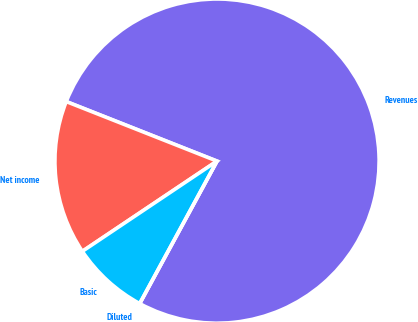Convert chart to OTSL. <chart><loc_0><loc_0><loc_500><loc_500><pie_chart><fcel>Revenues<fcel>Net income<fcel>Basic<fcel>Diluted<nl><fcel>76.92%<fcel>15.38%<fcel>7.69%<fcel>0.0%<nl></chart> 